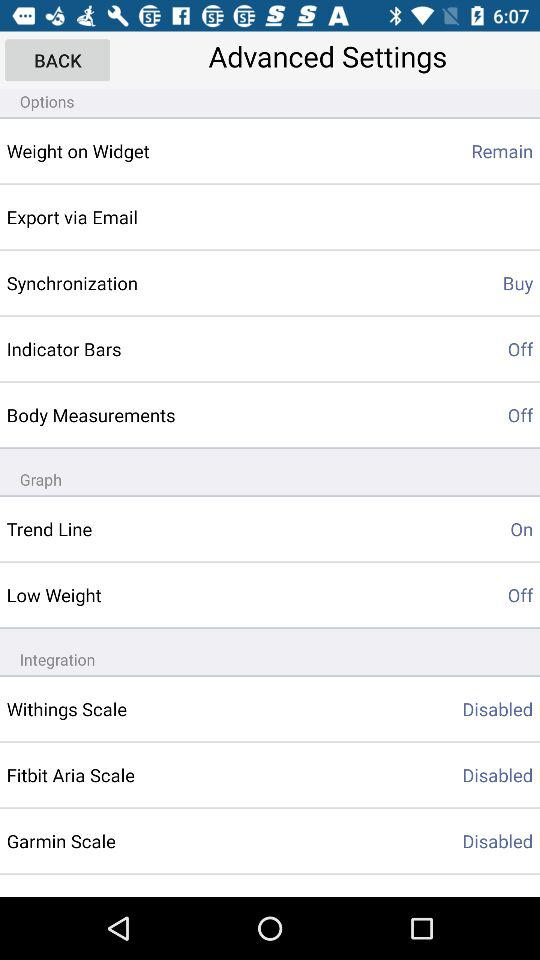How many items are disabled?
Answer the question using a single word or phrase. 3 